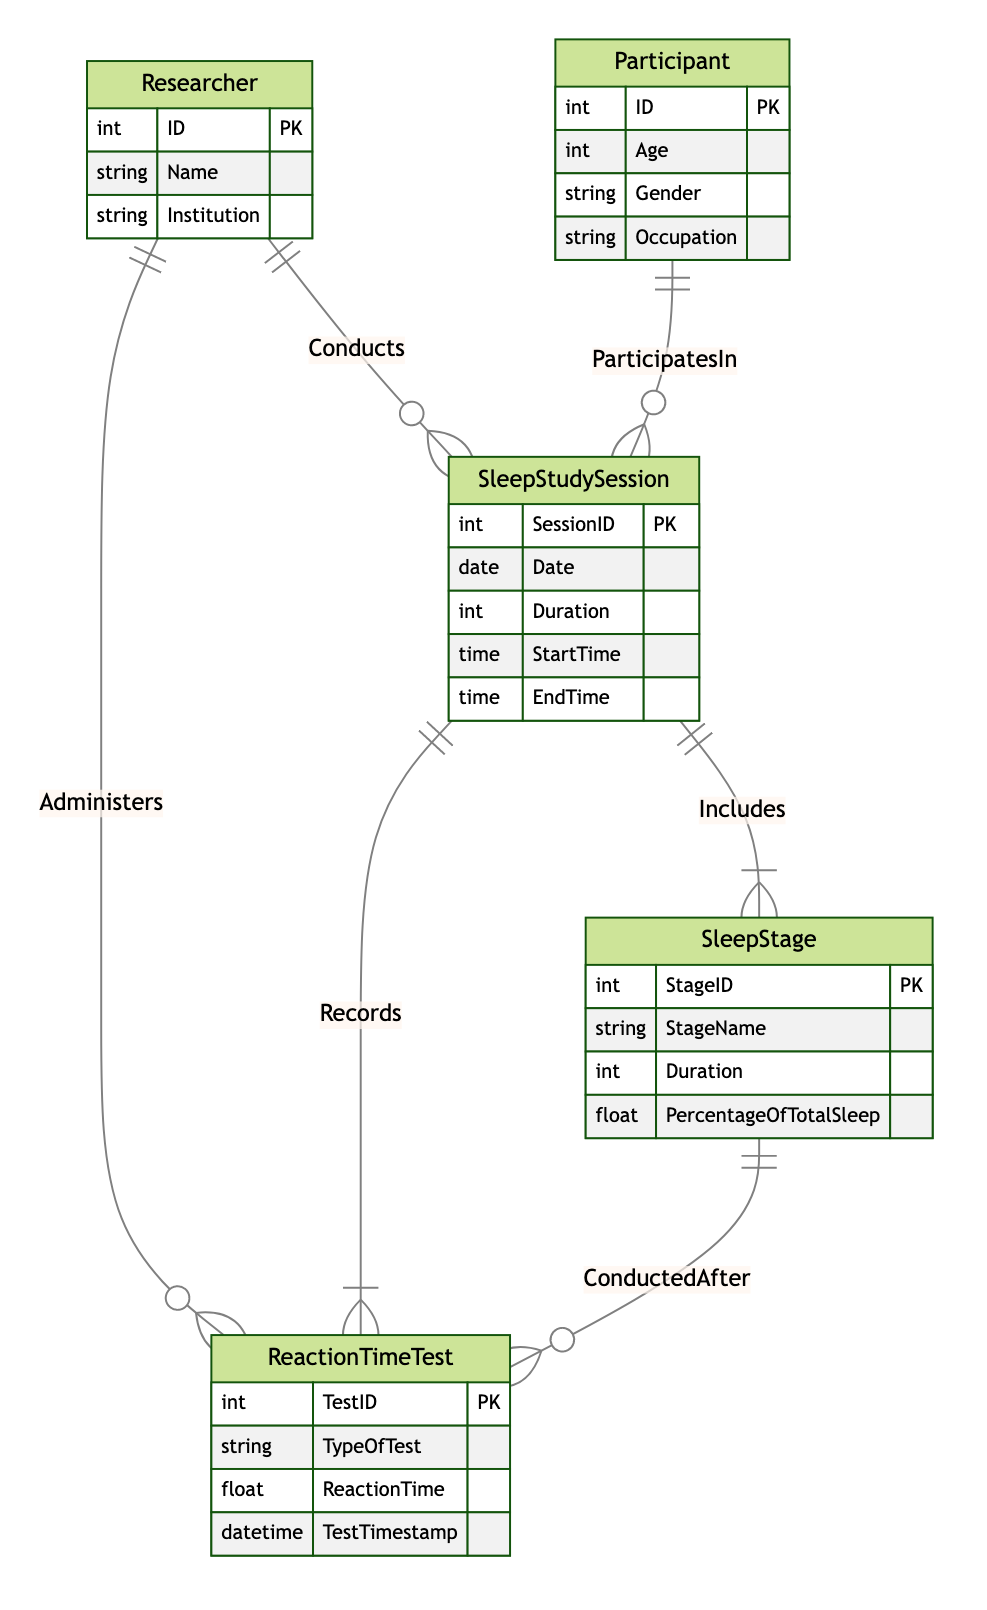What entity records sleep study sessions? The diagram shows the relationship "Records" connecting "SleepStudySession" and "ReactionTimeTest". This indicates that the "SleepStudySession" entity is the one that records associated reaction time tests.
Answer: SleepStudySession How many main entities are in the diagram? By counting the entities listed in the diagram, there are five main entities: Researcher, Participant, SleepStudySession, SleepStage, and ReactionTimeTest. Hence, the total count is five.
Answer: Five What relationship connects participants with sleep study sessions? The diagram specifies a relationship called "ParticipatesIn" connecting "Participant" and "SleepStudySession", indicating this is the link between them.
Answer: ParticipatesIn Which entity administers reaction time tests? The relationship "Administers" connects "Researcher" to "ReactionTimeTest", signifying that researchers are the ones who administer these tests.
Answer: Researcher What type of relationship exists between sleep stages and reaction time tests? The relationship "ConductedAfter" connects "SleepStage" and "ReactionTimeTest", indicating that reaction time tests are conducted after specific sleep stages.
Answer: ConductedAfter How many attributes are associated with the Participant entity? The Participant entity has four attributes listed in the diagram: ID, Age, Gender, and Occupation, resulting in a total of four attributes.
Answer: Four In what way does the SleepStudySession connect to the ReactionTimeTest? The diagram shows the "Records" relationship linking "SleepStudySession" and "ReactionTimeTest", indicating the connection through which session data is recorded alongside reaction time tests.
Answer: Records What is the primary key for the SleepStage entity? The primary key for the SleepStage entity, as indicated in the entity attributes, is "StageID".
Answer: StageID Do the Researcher and Participant entities have relationships with the same entity? Yes, both the Researcher and Participant entities have relationships with the SleepStudySession entity, with "Conducts" for the Researcher and "ParticipatesIn" for the Participant.
Answer: Yes 